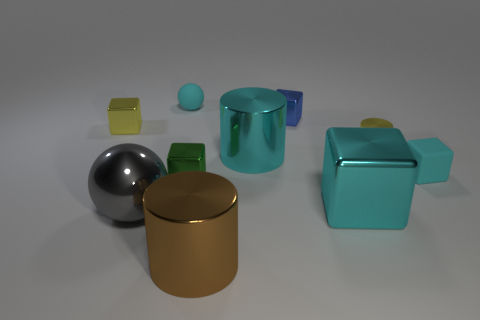Do the small object that is left of the tiny cyan rubber ball and the metallic cylinder that is behind the big cyan cylinder have the same color?
Your answer should be compact. Yes. There is a small green shiny block; are there any cyan objects right of it?
Provide a succinct answer. Yes. There is a object that is both behind the yellow block and in front of the small cyan sphere; what is its color?
Offer a terse response. Blue. Are there any cylinders that have the same color as the small rubber sphere?
Your answer should be compact. Yes. Does the tiny block that is behind the tiny yellow block have the same material as the large cylinder that is in front of the large gray thing?
Ensure brevity in your answer.  Yes. There is a rubber thing that is on the left side of the brown metallic cylinder; how big is it?
Your response must be concise. Small. The green metallic cube has what size?
Provide a short and direct response. Small. There is a metal block that is right of the small blue shiny object that is left of the large cyan metallic object to the right of the blue block; how big is it?
Keep it short and to the point. Large. Are there any cyan things that have the same material as the big sphere?
Your answer should be compact. Yes. What is the shape of the large brown thing?
Give a very brief answer. Cylinder. 